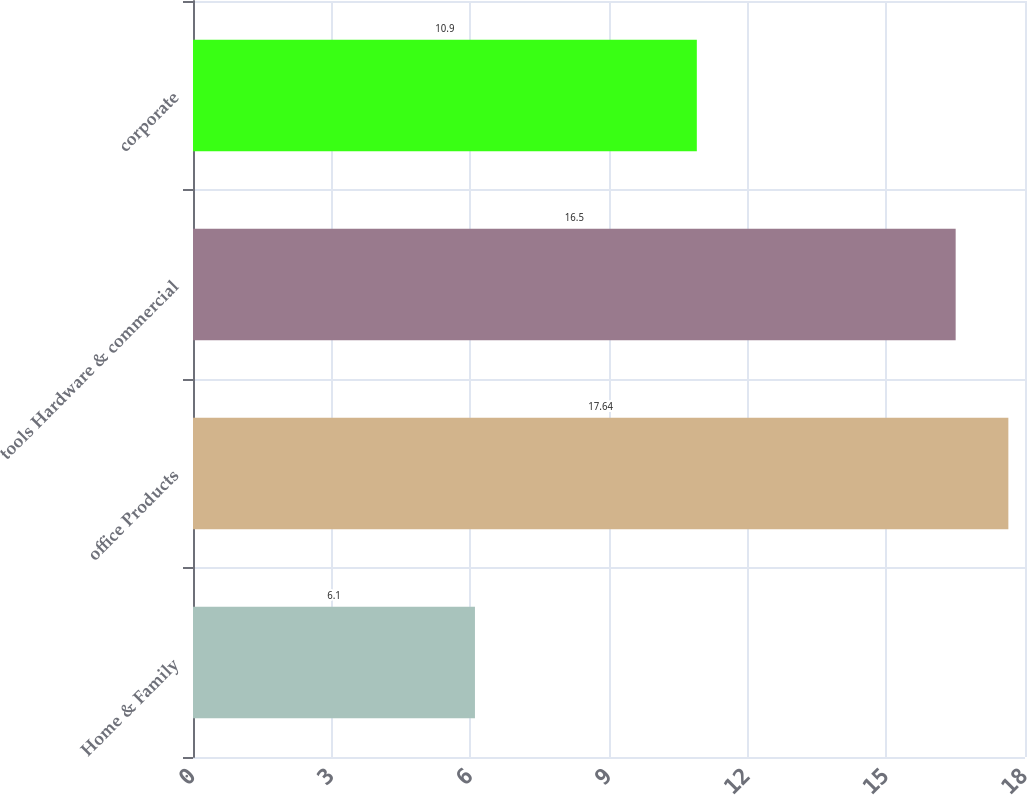<chart> <loc_0><loc_0><loc_500><loc_500><bar_chart><fcel>Home & Family<fcel>office Products<fcel>tools Hardware & commercial<fcel>corporate<nl><fcel>6.1<fcel>17.64<fcel>16.5<fcel>10.9<nl></chart> 